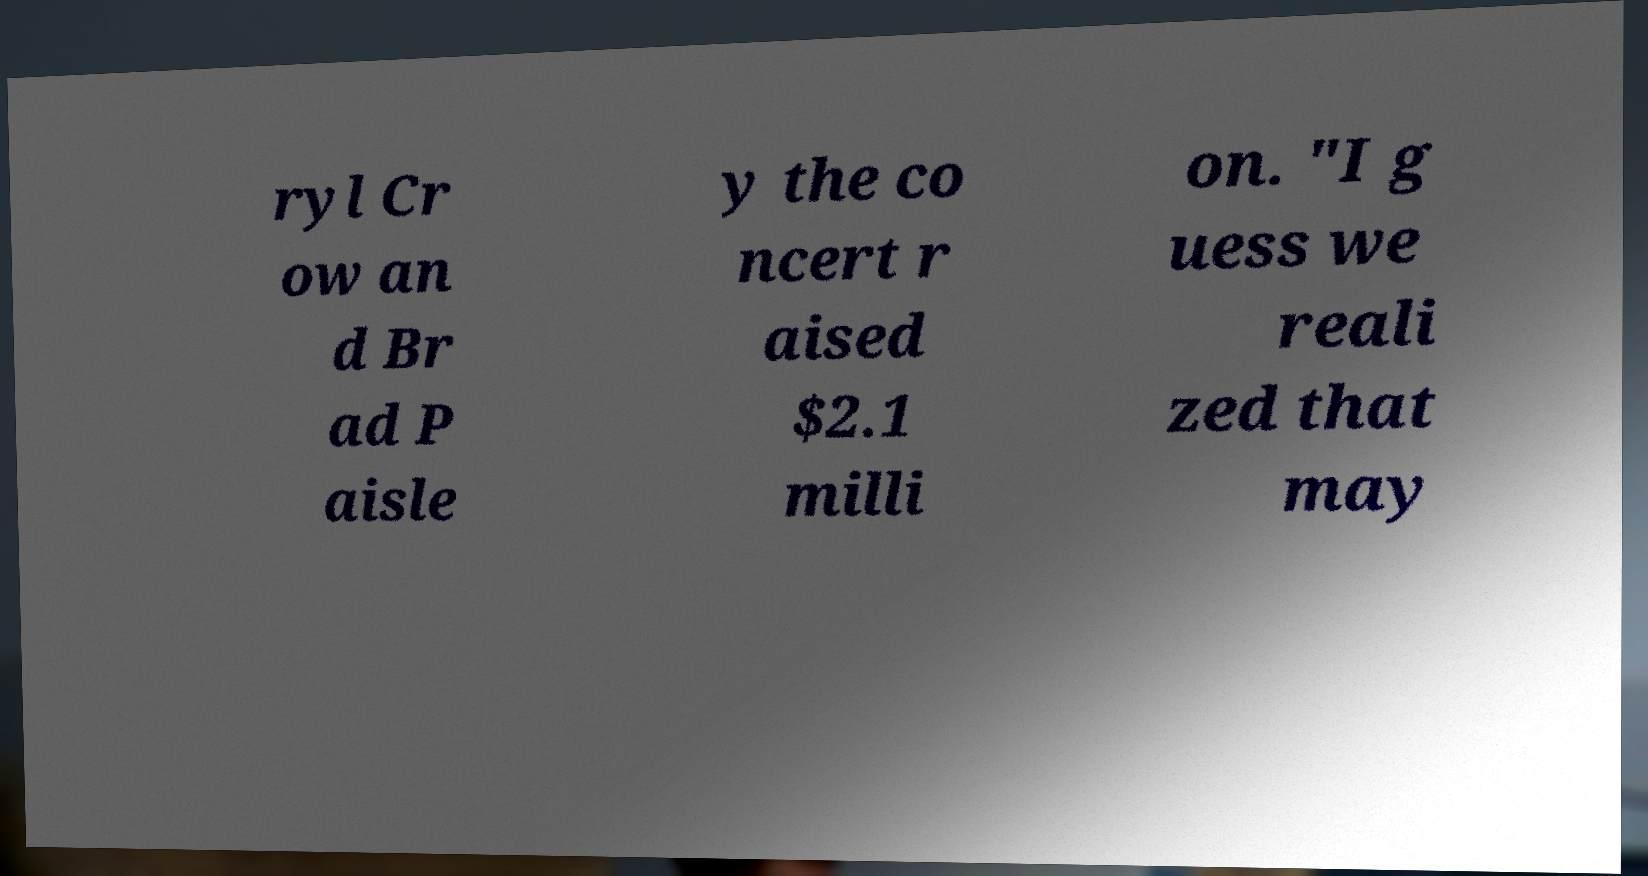I need the written content from this picture converted into text. Can you do that? ryl Cr ow an d Br ad P aisle y the co ncert r aised $2.1 milli on. "I g uess we reali zed that may 